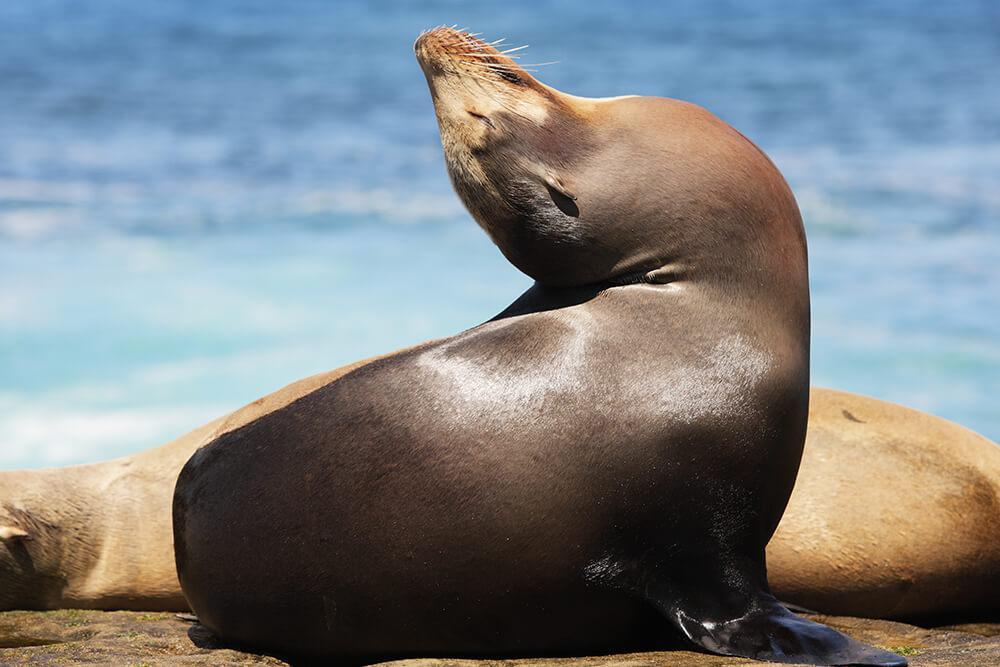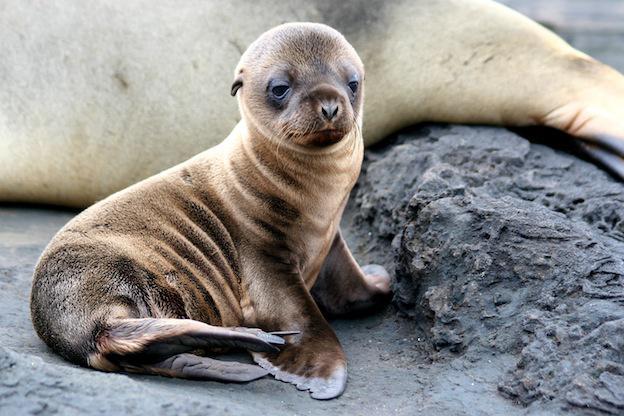The first image is the image on the left, the second image is the image on the right. Assess this claim about the two images: "One image contains exactly three seals.". Correct or not? Answer yes or no. No. 